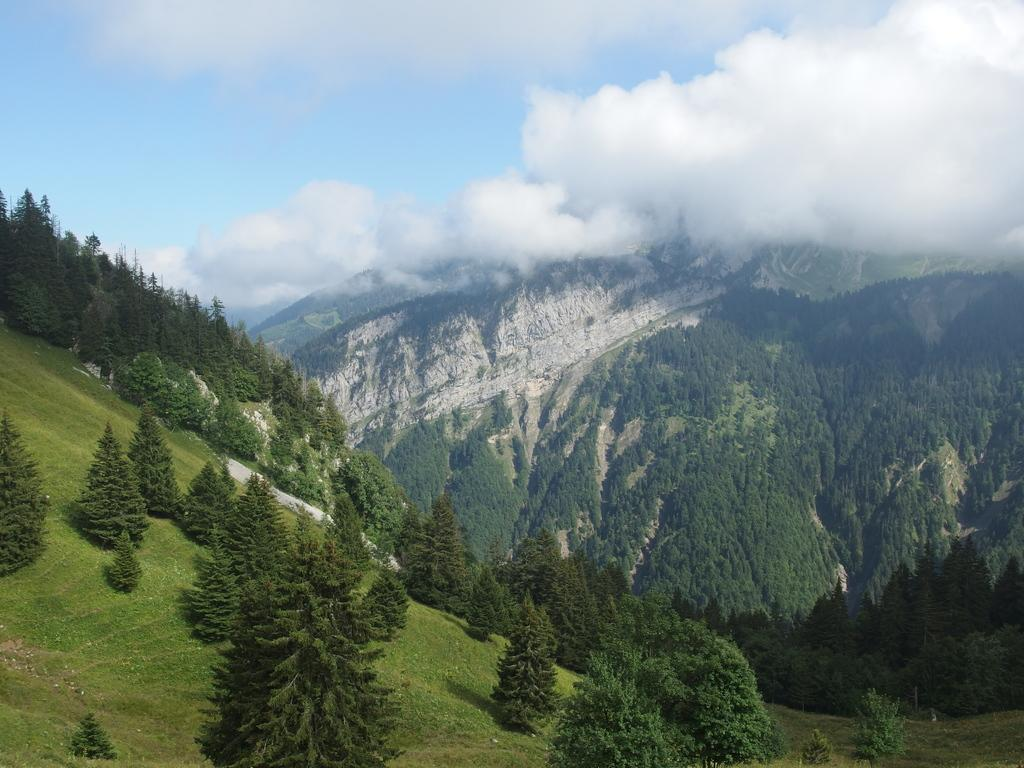What type of vegetation is present in the image? There are green trees in the image. What type of geographical feature can be seen in the image? There are mountains in the image. What is the color of the sky in the image? The sky is blue and white in the image. How many currents are flowing through the mountains in the image? There are no currents present in the image; it features green trees, mountains, and a blue and white sky. Can you tell me how many sisters are depicted in the image? There are no people, let alone sisters, depicted in the image. 